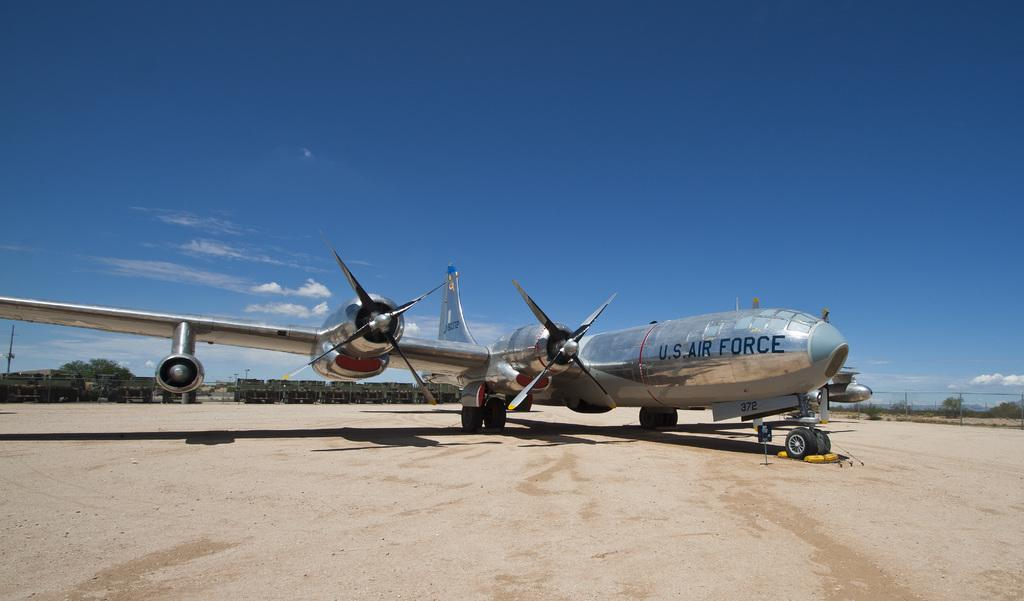<image>
Provide a brief description of the given image. A silver U.S. Air Force plane is at at military base. 